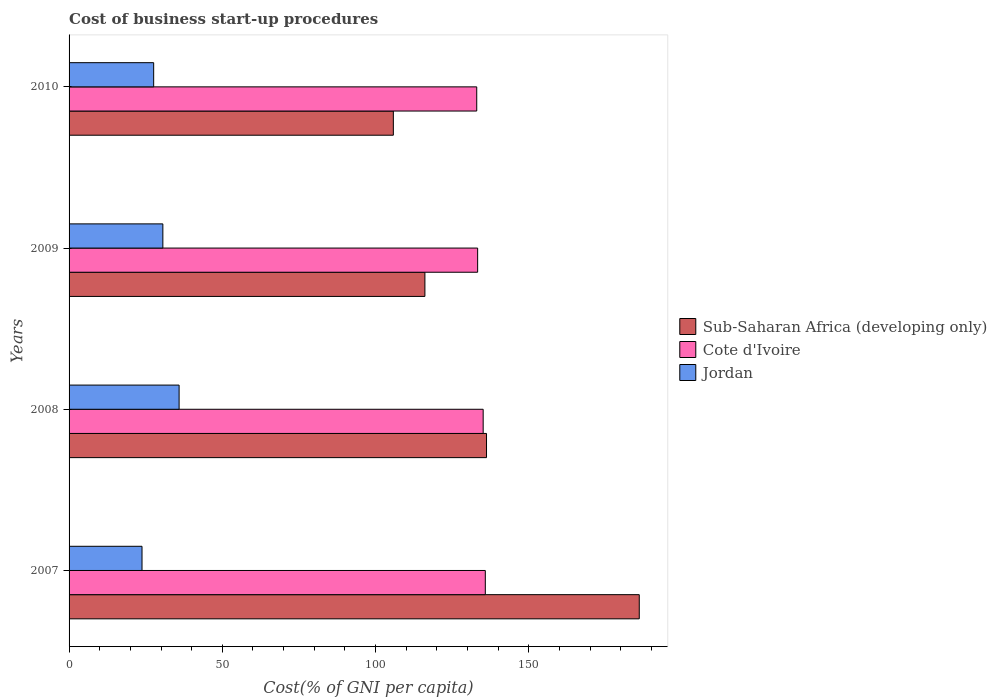Are the number of bars on each tick of the Y-axis equal?
Offer a terse response. Yes. How many bars are there on the 1st tick from the top?
Give a very brief answer. 3. How many bars are there on the 1st tick from the bottom?
Offer a terse response. 3. What is the cost of business start-up procedures in Jordan in 2008?
Your answer should be very brief. 35.9. Across all years, what is the maximum cost of business start-up procedures in Cote d'Ivoire?
Offer a very short reply. 135.8. Across all years, what is the minimum cost of business start-up procedures in Sub-Saharan Africa (developing only)?
Ensure brevity in your answer.  105.79. In which year was the cost of business start-up procedures in Jordan minimum?
Your answer should be very brief. 2007. What is the total cost of business start-up procedures in Cote d'Ivoire in the graph?
Offer a very short reply. 537.2. What is the difference between the cost of business start-up procedures in Jordan in 2007 and that in 2010?
Provide a short and direct response. -3.8. What is the difference between the cost of business start-up procedures in Jordan in 2010 and the cost of business start-up procedures in Sub-Saharan Africa (developing only) in 2007?
Your answer should be very brief. -158.43. What is the average cost of business start-up procedures in Cote d'Ivoire per year?
Keep it short and to the point. 134.3. In the year 2008, what is the difference between the cost of business start-up procedures in Sub-Saharan Africa (developing only) and cost of business start-up procedures in Cote d'Ivoire?
Provide a succinct answer. 1.1. What is the ratio of the cost of business start-up procedures in Cote d'Ivoire in 2008 to that in 2010?
Ensure brevity in your answer.  1.02. Is the cost of business start-up procedures in Sub-Saharan Africa (developing only) in 2007 less than that in 2008?
Offer a terse response. No. What is the difference between the highest and the second highest cost of business start-up procedures in Sub-Saharan Africa (developing only)?
Your answer should be very brief. 49.83. What is the difference between the highest and the lowest cost of business start-up procedures in Cote d'Ivoire?
Your answer should be compact. 2.8. What does the 2nd bar from the top in 2007 represents?
Your answer should be very brief. Cote d'Ivoire. What does the 3rd bar from the bottom in 2010 represents?
Give a very brief answer. Jordan. Is it the case that in every year, the sum of the cost of business start-up procedures in Cote d'Ivoire and cost of business start-up procedures in Jordan is greater than the cost of business start-up procedures in Sub-Saharan Africa (developing only)?
Keep it short and to the point. No. Are all the bars in the graph horizontal?
Give a very brief answer. Yes. What is the difference between two consecutive major ticks on the X-axis?
Offer a very short reply. 50. Are the values on the major ticks of X-axis written in scientific E-notation?
Provide a succinct answer. No. Does the graph contain any zero values?
Your response must be concise. No. Does the graph contain grids?
Offer a terse response. No. How many legend labels are there?
Keep it short and to the point. 3. What is the title of the graph?
Your answer should be compact. Cost of business start-up procedures. Does "Andorra" appear as one of the legend labels in the graph?
Offer a terse response. No. What is the label or title of the X-axis?
Your answer should be compact. Cost(% of GNI per capita). What is the Cost(% of GNI per capita) in Sub-Saharan Africa (developing only) in 2007?
Give a very brief answer. 186.03. What is the Cost(% of GNI per capita) in Cote d'Ivoire in 2007?
Your answer should be compact. 135.8. What is the Cost(% of GNI per capita) of Jordan in 2007?
Your answer should be compact. 23.8. What is the Cost(% of GNI per capita) of Sub-Saharan Africa (developing only) in 2008?
Offer a terse response. 136.2. What is the Cost(% of GNI per capita) of Cote d'Ivoire in 2008?
Your answer should be compact. 135.1. What is the Cost(% of GNI per capita) in Jordan in 2008?
Make the answer very short. 35.9. What is the Cost(% of GNI per capita) of Sub-Saharan Africa (developing only) in 2009?
Ensure brevity in your answer.  116.09. What is the Cost(% of GNI per capita) in Cote d'Ivoire in 2009?
Offer a terse response. 133.3. What is the Cost(% of GNI per capita) in Jordan in 2009?
Offer a very short reply. 30.6. What is the Cost(% of GNI per capita) of Sub-Saharan Africa (developing only) in 2010?
Provide a succinct answer. 105.79. What is the Cost(% of GNI per capita) of Cote d'Ivoire in 2010?
Your answer should be compact. 133. What is the Cost(% of GNI per capita) of Jordan in 2010?
Offer a terse response. 27.6. Across all years, what is the maximum Cost(% of GNI per capita) of Sub-Saharan Africa (developing only)?
Give a very brief answer. 186.03. Across all years, what is the maximum Cost(% of GNI per capita) in Cote d'Ivoire?
Your answer should be very brief. 135.8. Across all years, what is the maximum Cost(% of GNI per capita) of Jordan?
Make the answer very short. 35.9. Across all years, what is the minimum Cost(% of GNI per capita) of Sub-Saharan Africa (developing only)?
Offer a very short reply. 105.79. Across all years, what is the minimum Cost(% of GNI per capita) in Cote d'Ivoire?
Make the answer very short. 133. Across all years, what is the minimum Cost(% of GNI per capita) of Jordan?
Give a very brief answer. 23.8. What is the total Cost(% of GNI per capita) of Sub-Saharan Africa (developing only) in the graph?
Provide a succinct answer. 544.11. What is the total Cost(% of GNI per capita) of Cote d'Ivoire in the graph?
Offer a terse response. 537.2. What is the total Cost(% of GNI per capita) in Jordan in the graph?
Give a very brief answer. 117.9. What is the difference between the Cost(% of GNI per capita) of Sub-Saharan Africa (developing only) in 2007 and that in 2008?
Give a very brief answer. 49.83. What is the difference between the Cost(% of GNI per capita) of Cote d'Ivoire in 2007 and that in 2008?
Offer a very short reply. 0.7. What is the difference between the Cost(% of GNI per capita) in Sub-Saharan Africa (developing only) in 2007 and that in 2009?
Provide a short and direct response. 69.93. What is the difference between the Cost(% of GNI per capita) in Sub-Saharan Africa (developing only) in 2007 and that in 2010?
Ensure brevity in your answer.  80.23. What is the difference between the Cost(% of GNI per capita) in Cote d'Ivoire in 2007 and that in 2010?
Keep it short and to the point. 2.8. What is the difference between the Cost(% of GNI per capita) in Jordan in 2007 and that in 2010?
Offer a very short reply. -3.8. What is the difference between the Cost(% of GNI per capita) in Sub-Saharan Africa (developing only) in 2008 and that in 2009?
Give a very brief answer. 20.1. What is the difference between the Cost(% of GNI per capita) in Cote d'Ivoire in 2008 and that in 2009?
Offer a terse response. 1.8. What is the difference between the Cost(% of GNI per capita) of Jordan in 2008 and that in 2009?
Your answer should be very brief. 5.3. What is the difference between the Cost(% of GNI per capita) in Sub-Saharan Africa (developing only) in 2008 and that in 2010?
Give a very brief answer. 30.4. What is the difference between the Cost(% of GNI per capita) in Cote d'Ivoire in 2008 and that in 2010?
Ensure brevity in your answer.  2.1. What is the difference between the Cost(% of GNI per capita) of Sub-Saharan Africa (developing only) in 2009 and that in 2010?
Ensure brevity in your answer.  10.3. What is the difference between the Cost(% of GNI per capita) of Jordan in 2009 and that in 2010?
Make the answer very short. 3. What is the difference between the Cost(% of GNI per capita) in Sub-Saharan Africa (developing only) in 2007 and the Cost(% of GNI per capita) in Cote d'Ivoire in 2008?
Provide a short and direct response. 50.93. What is the difference between the Cost(% of GNI per capita) of Sub-Saharan Africa (developing only) in 2007 and the Cost(% of GNI per capita) of Jordan in 2008?
Your response must be concise. 150.13. What is the difference between the Cost(% of GNI per capita) of Cote d'Ivoire in 2007 and the Cost(% of GNI per capita) of Jordan in 2008?
Your response must be concise. 99.9. What is the difference between the Cost(% of GNI per capita) of Sub-Saharan Africa (developing only) in 2007 and the Cost(% of GNI per capita) of Cote d'Ivoire in 2009?
Your answer should be very brief. 52.73. What is the difference between the Cost(% of GNI per capita) in Sub-Saharan Africa (developing only) in 2007 and the Cost(% of GNI per capita) in Jordan in 2009?
Your answer should be very brief. 155.43. What is the difference between the Cost(% of GNI per capita) of Cote d'Ivoire in 2007 and the Cost(% of GNI per capita) of Jordan in 2009?
Keep it short and to the point. 105.2. What is the difference between the Cost(% of GNI per capita) in Sub-Saharan Africa (developing only) in 2007 and the Cost(% of GNI per capita) in Cote d'Ivoire in 2010?
Provide a succinct answer. 53.03. What is the difference between the Cost(% of GNI per capita) of Sub-Saharan Africa (developing only) in 2007 and the Cost(% of GNI per capita) of Jordan in 2010?
Make the answer very short. 158.43. What is the difference between the Cost(% of GNI per capita) of Cote d'Ivoire in 2007 and the Cost(% of GNI per capita) of Jordan in 2010?
Offer a very short reply. 108.2. What is the difference between the Cost(% of GNI per capita) of Sub-Saharan Africa (developing only) in 2008 and the Cost(% of GNI per capita) of Cote d'Ivoire in 2009?
Offer a very short reply. 2.9. What is the difference between the Cost(% of GNI per capita) in Sub-Saharan Africa (developing only) in 2008 and the Cost(% of GNI per capita) in Jordan in 2009?
Provide a succinct answer. 105.6. What is the difference between the Cost(% of GNI per capita) of Cote d'Ivoire in 2008 and the Cost(% of GNI per capita) of Jordan in 2009?
Provide a short and direct response. 104.5. What is the difference between the Cost(% of GNI per capita) in Sub-Saharan Africa (developing only) in 2008 and the Cost(% of GNI per capita) in Cote d'Ivoire in 2010?
Provide a short and direct response. 3.2. What is the difference between the Cost(% of GNI per capita) in Sub-Saharan Africa (developing only) in 2008 and the Cost(% of GNI per capita) in Jordan in 2010?
Your answer should be very brief. 108.6. What is the difference between the Cost(% of GNI per capita) of Cote d'Ivoire in 2008 and the Cost(% of GNI per capita) of Jordan in 2010?
Offer a terse response. 107.5. What is the difference between the Cost(% of GNI per capita) of Sub-Saharan Africa (developing only) in 2009 and the Cost(% of GNI per capita) of Cote d'Ivoire in 2010?
Offer a terse response. -16.91. What is the difference between the Cost(% of GNI per capita) in Sub-Saharan Africa (developing only) in 2009 and the Cost(% of GNI per capita) in Jordan in 2010?
Your response must be concise. 88.49. What is the difference between the Cost(% of GNI per capita) of Cote d'Ivoire in 2009 and the Cost(% of GNI per capita) of Jordan in 2010?
Ensure brevity in your answer.  105.7. What is the average Cost(% of GNI per capita) in Sub-Saharan Africa (developing only) per year?
Offer a very short reply. 136.03. What is the average Cost(% of GNI per capita) of Cote d'Ivoire per year?
Ensure brevity in your answer.  134.3. What is the average Cost(% of GNI per capita) in Jordan per year?
Ensure brevity in your answer.  29.48. In the year 2007, what is the difference between the Cost(% of GNI per capita) of Sub-Saharan Africa (developing only) and Cost(% of GNI per capita) of Cote d'Ivoire?
Your response must be concise. 50.23. In the year 2007, what is the difference between the Cost(% of GNI per capita) in Sub-Saharan Africa (developing only) and Cost(% of GNI per capita) in Jordan?
Offer a very short reply. 162.23. In the year 2007, what is the difference between the Cost(% of GNI per capita) in Cote d'Ivoire and Cost(% of GNI per capita) in Jordan?
Your response must be concise. 112. In the year 2008, what is the difference between the Cost(% of GNI per capita) in Sub-Saharan Africa (developing only) and Cost(% of GNI per capita) in Cote d'Ivoire?
Your answer should be very brief. 1.1. In the year 2008, what is the difference between the Cost(% of GNI per capita) of Sub-Saharan Africa (developing only) and Cost(% of GNI per capita) of Jordan?
Keep it short and to the point. 100.3. In the year 2008, what is the difference between the Cost(% of GNI per capita) in Cote d'Ivoire and Cost(% of GNI per capita) in Jordan?
Your answer should be very brief. 99.2. In the year 2009, what is the difference between the Cost(% of GNI per capita) in Sub-Saharan Africa (developing only) and Cost(% of GNI per capita) in Cote d'Ivoire?
Provide a succinct answer. -17.21. In the year 2009, what is the difference between the Cost(% of GNI per capita) in Sub-Saharan Africa (developing only) and Cost(% of GNI per capita) in Jordan?
Ensure brevity in your answer.  85.49. In the year 2009, what is the difference between the Cost(% of GNI per capita) in Cote d'Ivoire and Cost(% of GNI per capita) in Jordan?
Keep it short and to the point. 102.7. In the year 2010, what is the difference between the Cost(% of GNI per capita) of Sub-Saharan Africa (developing only) and Cost(% of GNI per capita) of Cote d'Ivoire?
Give a very brief answer. -27.21. In the year 2010, what is the difference between the Cost(% of GNI per capita) of Sub-Saharan Africa (developing only) and Cost(% of GNI per capita) of Jordan?
Your response must be concise. 78.19. In the year 2010, what is the difference between the Cost(% of GNI per capita) in Cote d'Ivoire and Cost(% of GNI per capita) in Jordan?
Provide a short and direct response. 105.4. What is the ratio of the Cost(% of GNI per capita) of Sub-Saharan Africa (developing only) in 2007 to that in 2008?
Offer a very short reply. 1.37. What is the ratio of the Cost(% of GNI per capita) in Jordan in 2007 to that in 2008?
Offer a very short reply. 0.66. What is the ratio of the Cost(% of GNI per capita) of Sub-Saharan Africa (developing only) in 2007 to that in 2009?
Provide a succinct answer. 1.6. What is the ratio of the Cost(% of GNI per capita) in Cote d'Ivoire in 2007 to that in 2009?
Offer a very short reply. 1.02. What is the ratio of the Cost(% of GNI per capita) of Sub-Saharan Africa (developing only) in 2007 to that in 2010?
Your answer should be compact. 1.76. What is the ratio of the Cost(% of GNI per capita) of Cote d'Ivoire in 2007 to that in 2010?
Keep it short and to the point. 1.02. What is the ratio of the Cost(% of GNI per capita) of Jordan in 2007 to that in 2010?
Your answer should be compact. 0.86. What is the ratio of the Cost(% of GNI per capita) of Sub-Saharan Africa (developing only) in 2008 to that in 2009?
Ensure brevity in your answer.  1.17. What is the ratio of the Cost(% of GNI per capita) in Cote d'Ivoire in 2008 to that in 2009?
Offer a terse response. 1.01. What is the ratio of the Cost(% of GNI per capita) in Jordan in 2008 to that in 2009?
Ensure brevity in your answer.  1.17. What is the ratio of the Cost(% of GNI per capita) of Sub-Saharan Africa (developing only) in 2008 to that in 2010?
Ensure brevity in your answer.  1.29. What is the ratio of the Cost(% of GNI per capita) in Cote d'Ivoire in 2008 to that in 2010?
Give a very brief answer. 1.02. What is the ratio of the Cost(% of GNI per capita) in Jordan in 2008 to that in 2010?
Keep it short and to the point. 1.3. What is the ratio of the Cost(% of GNI per capita) of Sub-Saharan Africa (developing only) in 2009 to that in 2010?
Provide a short and direct response. 1.1. What is the ratio of the Cost(% of GNI per capita) in Cote d'Ivoire in 2009 to that in 2010?
Offer a terse response. 1. What is the ratio of the Cost(% of GNI per capita) of Jordan in 2009 to that in 2010?
Give a very brief answer. 1.11. What is the difference between the highest and the second highest Cost(% of GNI per capita) in Sub-Saharan Africa (developing only)?
Ensure brevity in your answer.  49.83. What is the difference between the highest and the second highest Cost(% of GNI per capita) in Cote d'Ivoire?
Make the answer very short. 0.7. What is the difference between the highest and the second highest Cost(% of GNI per capita) in Jordan?
Give a very brief answer. 5.3. What is the difference between the highest and the lowest Cost(% of GNI per capita) in Sub-Saharan Africa (developing only)?
Provide a short and direct response. 80.23. What is the difference between the highest and the lowest Cost(% of GNI per capita) of Cote d'Ivoire?
Give a very brief answer. 2.8. What is the difference between the highest and the lowest Cost(% of GNI per capita) of Jordan?
Your answer should be compact. 12.1. 